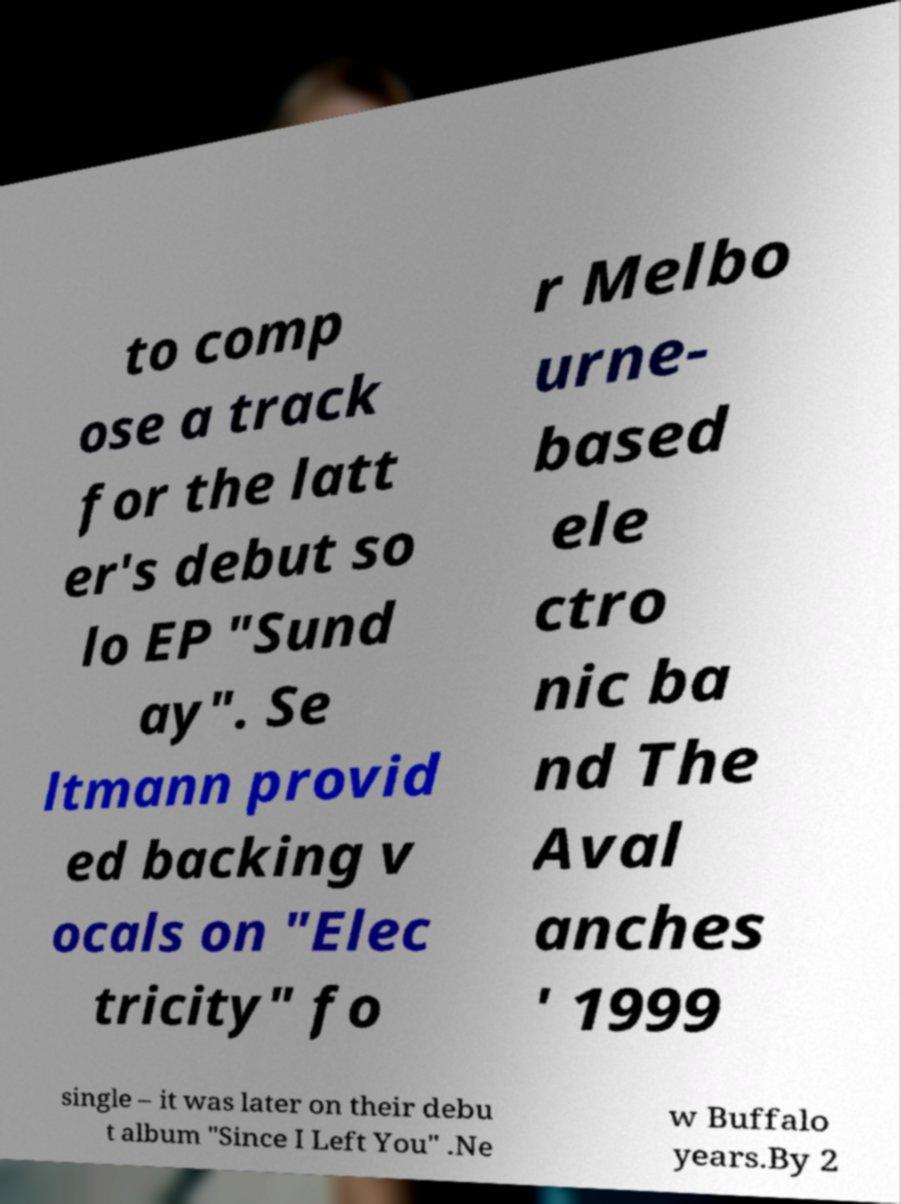There's text embedded in this image that I need extracted. Can you transcribe it verbatim? to comp ose a track for the latt er's debut so lo EP "Sund ay". Se ltmann provid ed backing v ocals on "Elec tricity" fo r Melbo urne- based ele ctro nic ba nd The Aval anches ' 1999 single – it was later on their debu t album "Since I Left You" .Ne w Buffalo years.By 2 